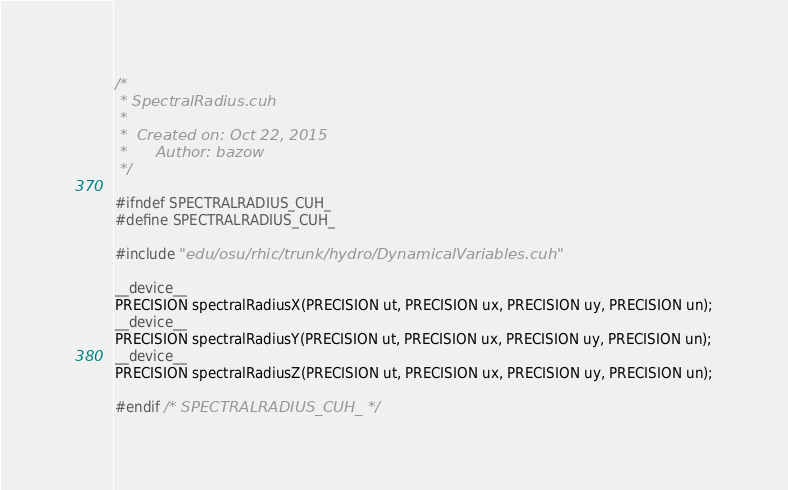Convert code to text. <code><loc_0><loc_0><loc_500><loc_500><_Cuda_>/*
 * SpectralRadius.cuh
 *
 *  Created on: Oct 22, 2015
 *      Author: bazow
 */

#ifndef SPECTRALRADIUS_CUH_
#define SPECTRALRADIUS_CUH_

#include "edu/osu/rhic/trunk/hydro/DynamicalVariables.cuh"

__device__ 
PRECISION spectralRadiusX(PRECISION ut, PRECISION ux, PRECISION uy, PRECISION un);
__device__ 
PRECISION spectralRadiusY(PRECISION ut, PRECISION ux, PRECISION uy, PRECISION un);
__device__ 
PRECISION spectralRadiusZ(PRECISION ut, PRECISION ux, PRECISION uy, PRECISION un);

#endif /* SPECTRALRADIUS_CUH_ */
</code> 